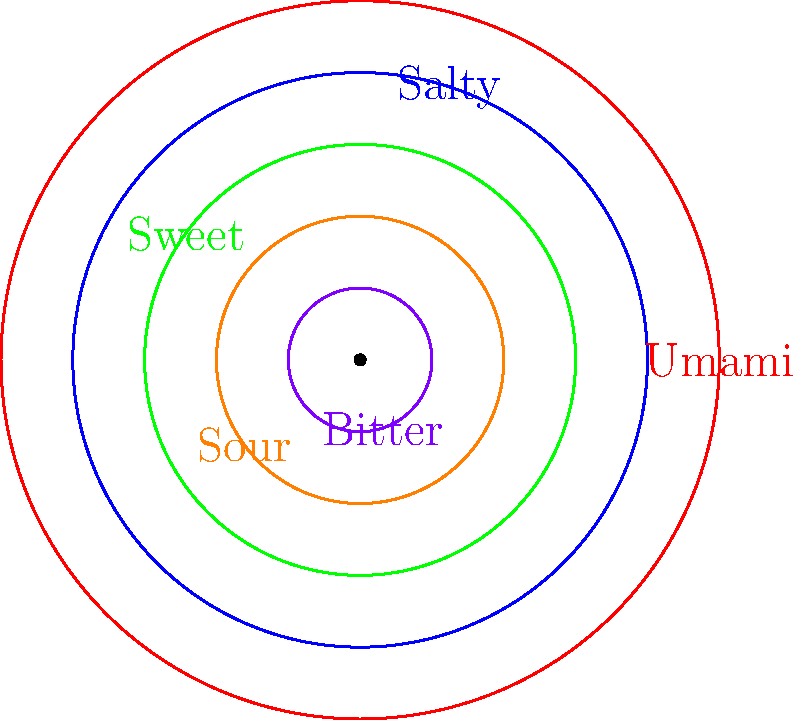In the polar rose chart representing the flavor profile of a popular vegetarian dish, which flavor characteristic is most prominent? To determine the most prominent flavor characteristic in the polar rose chart:

1. Observe the five flavor characteristics represented: Umami, Salty, Sweet, Sour, and Bitter.
2. Each characteristic is represented by a colored petal in the polar rose chart.
3. The size of each petal corresponds to the intensity of that flavor.
4. Compare the sizes of all petals:
   - Umami (red): Largest petal
   - Salty (blue): Second largest
   - Sweet (green): Third largest
   - Sour (orange): Fourth largest
   - Bitter (purple): Smallest petal
5. The largest petal represents the most prominent flavor characteristic.

Therefore, the most prominent flavor characteristic in this vegetarian dish is Umami, represented by the largest (red) petal in the polar rose chart.
Answer: Umami 